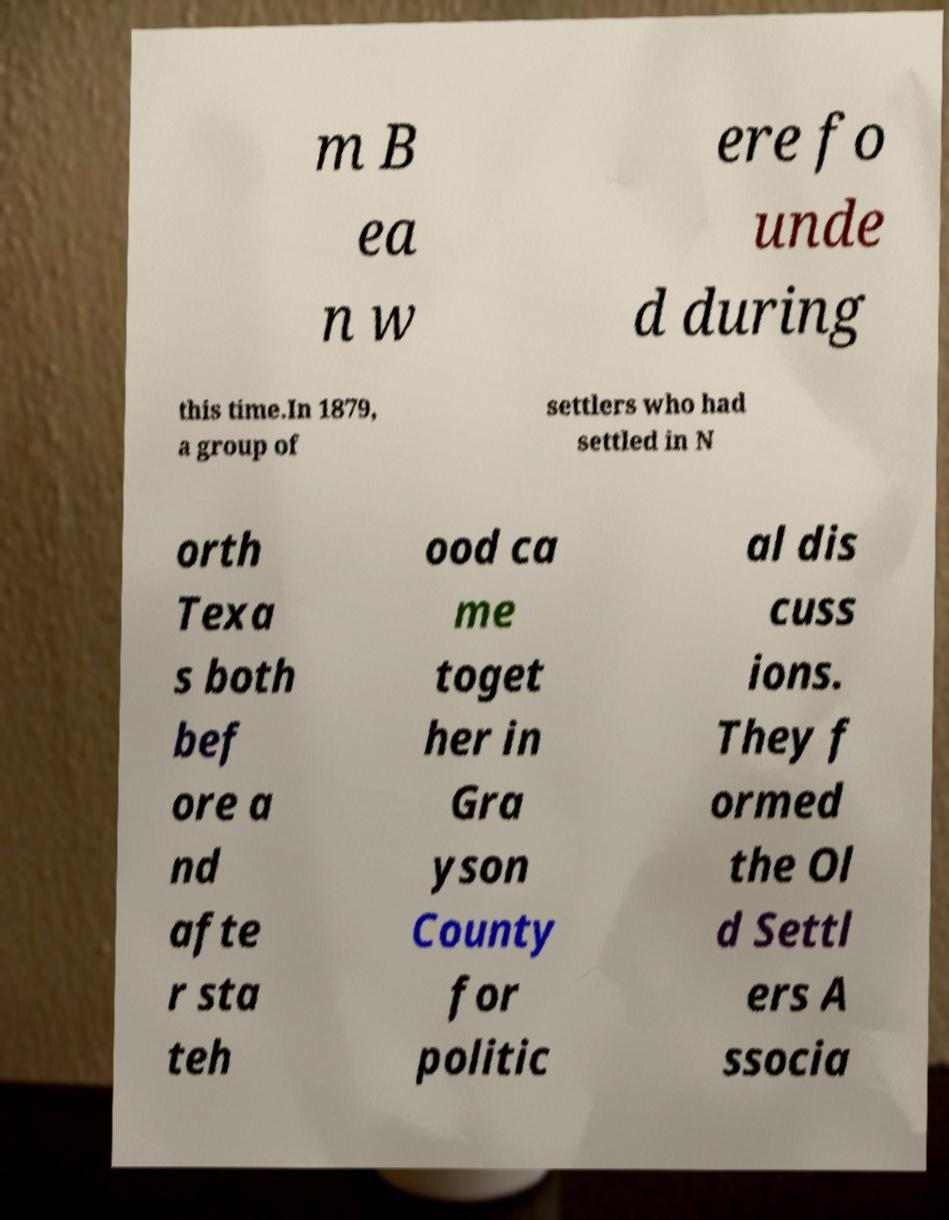Please identify and transcribe the text found in this image. m B ea n w ere fo unde d during this time.In 1879, a group of settlers who had settled in N orth Texa s both bef ore a nd afte r sta teh ood ca me toget her in Gra yson County for politic al dis cuss ions. They f ormed the Ol d Settl ers A ssocia 